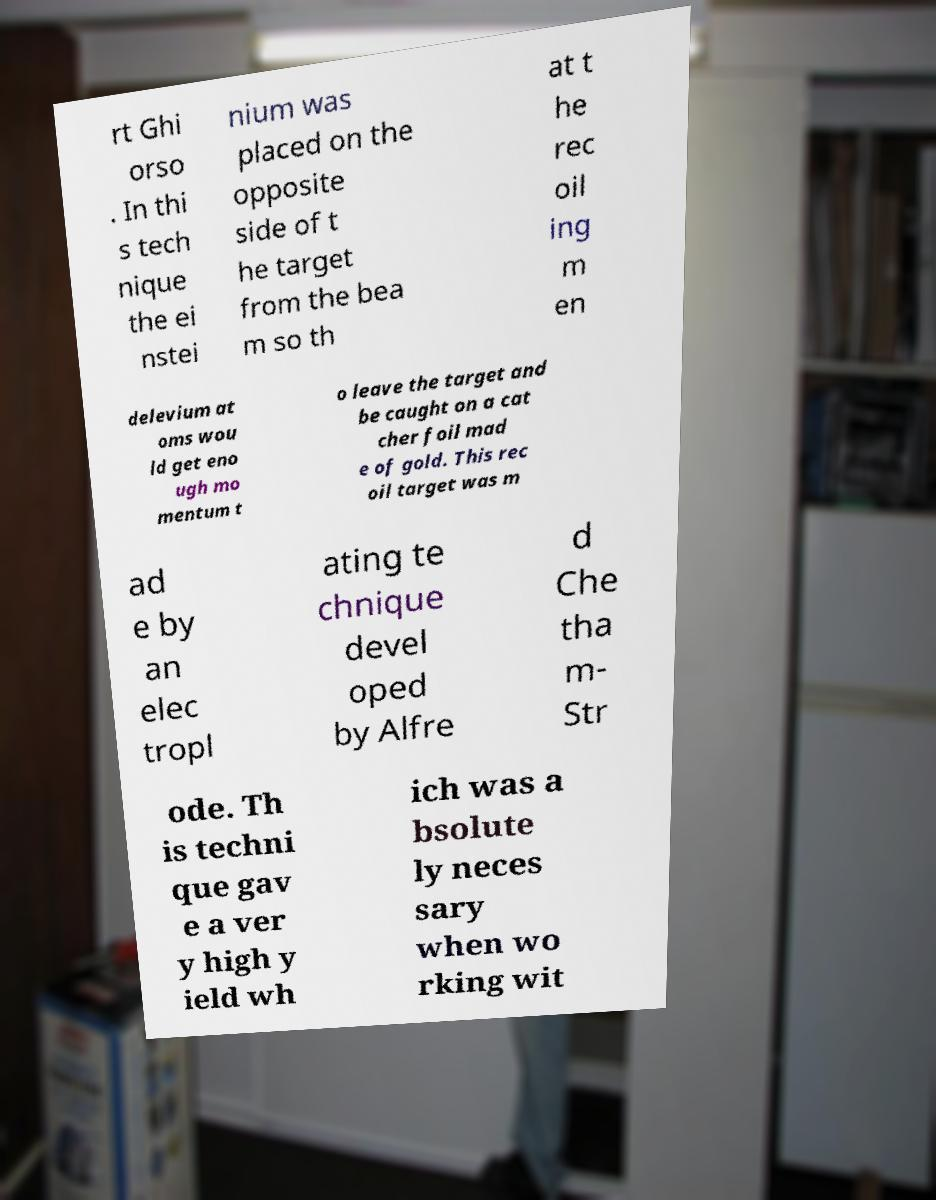For documentation purposes, I need the text within this image transcribed. Could you provide that? rt Ghi orso . In thi s tech nique the ei nstei nium was placed on the opposite side of t he target from the bea m so th at t he rec oil ing m en delevium at oms wou ld get eno ugh mo mentum t o leave the target and be caught on a cat cher foil mad e of gold. This rec oil target was m ad e by an elec tropl ating te chnique devel oped by Alfre d Che tha m- Str ode. Th is techni que gav e a ver y high y ield wh ich was a bsolute ly neces sary when wo rking wit 